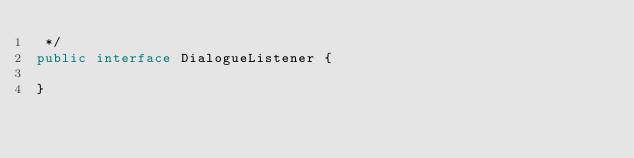Convert code to text. <code><loc_0><loc_0><loc_500><loc_500><_Java_> */
public interface DialogueListener {

}
</code> 